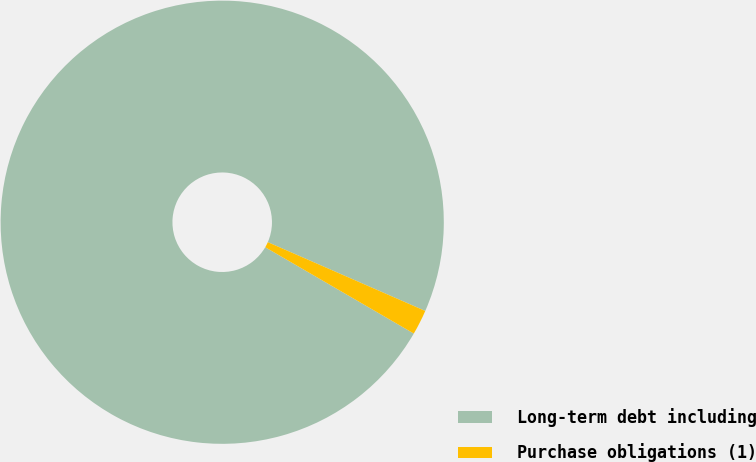Convert chart to OTSL. <chart><loc_0><loc_0><loc_500><loc_500><pie_chart><fcel>Long-term debt including<fcel>Purchase obligations (1)<nl><fcel>98.18%<fcel>1.82%<nl></chart> 